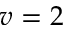Convert formula to latex. <formula><loc_0><loc_0><loc_500><loc_500>v = 2</formula> 